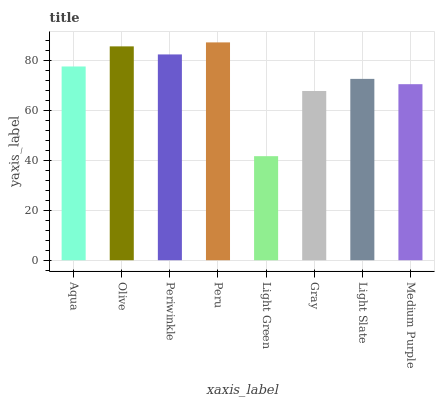Is Light Green the minimum?
Answer yes or no. Yes. Is Peru the maximum?
Answer yes or no. Yes. Is Olive the minimum?
Answer yes or no. No. Is Olive the maximum?
Answer yes or no. No. Is Olive greater than Aqua?
Answer yes or no. Yes. Is Aqua less than Olive?
Answer yes or no. Yes. Is Aqua greater than Olive?
Answer yes or no. No. Is Olive less than Aqua?
Answer yes or no. No. Is Aqua the high median?
Answer yes or no. Yes. Is Light Slate the low median?
Answer yes or no. Yes. Is Light Green the high median?
Answer yes or no. No. Is Medium Purple the low median?
Answer yes or no. No. 